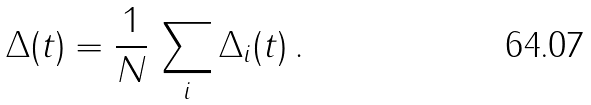Convert formula to latex. <formula><loc_0><loc_0><loc_500><loc_500>\Delta ( t ) = \frac { 1 } { N } \, \sum _ { i } \Delta _ { i } ( t ) \, .</formula> 